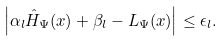<formula> <loc_0><loc_0><loc_500><loc_500>\left | \alpha _ { l } \hat { H } _ { \Psi } ( x ) + \beta _ { l } - L _ { \Psi } ( x ) \right | \leq \epsilon _ { l } .</formula> 